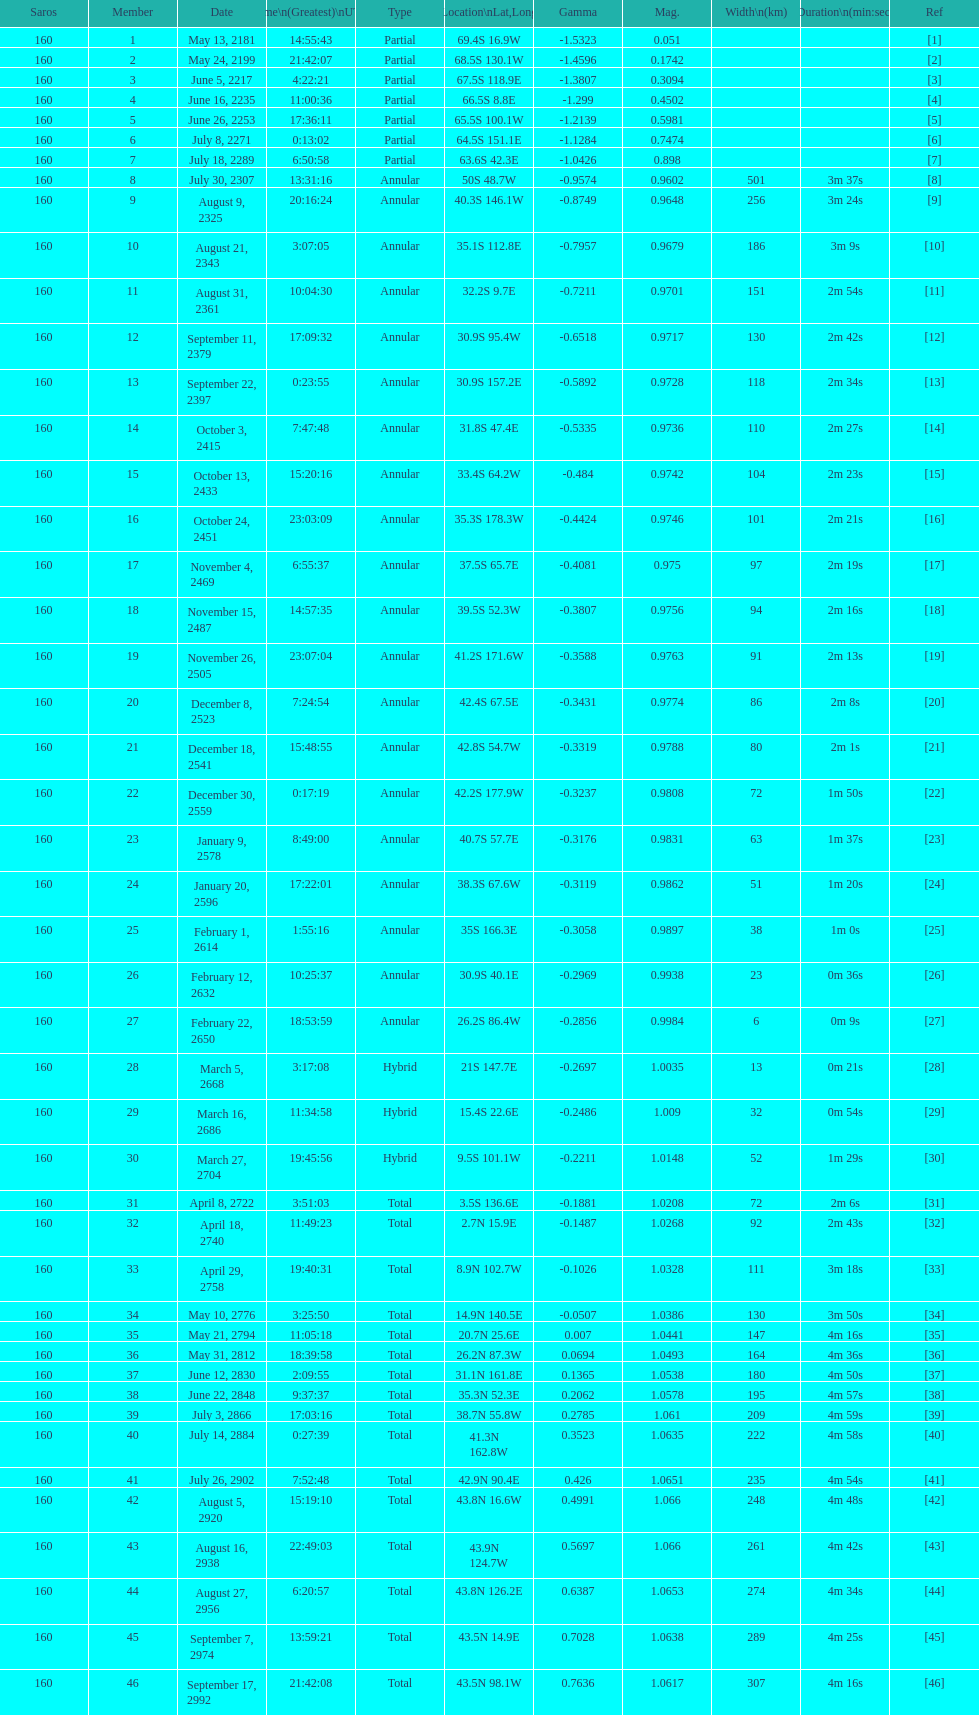When did the saros occur prior to october 3, 2415? 7:47:48. 